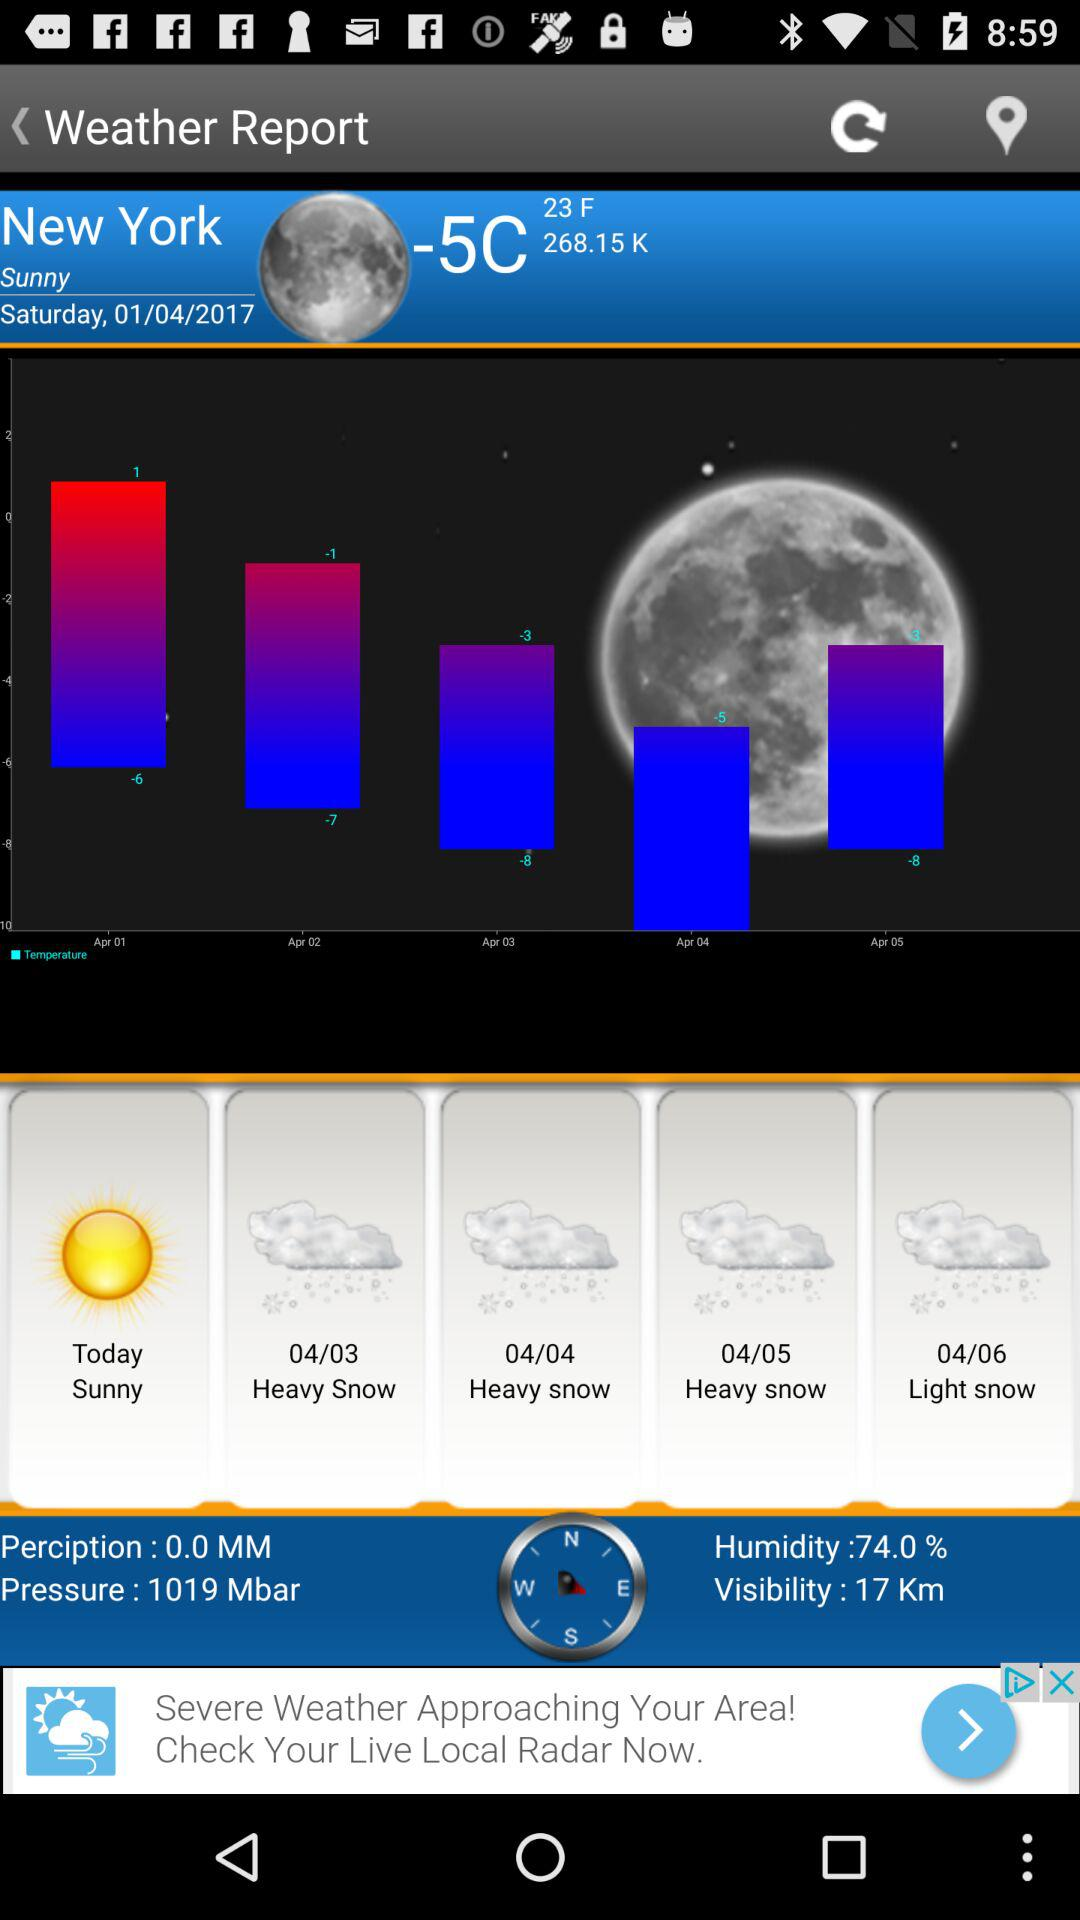How much is the recorded temperature? The recorded temperature is -5C. 